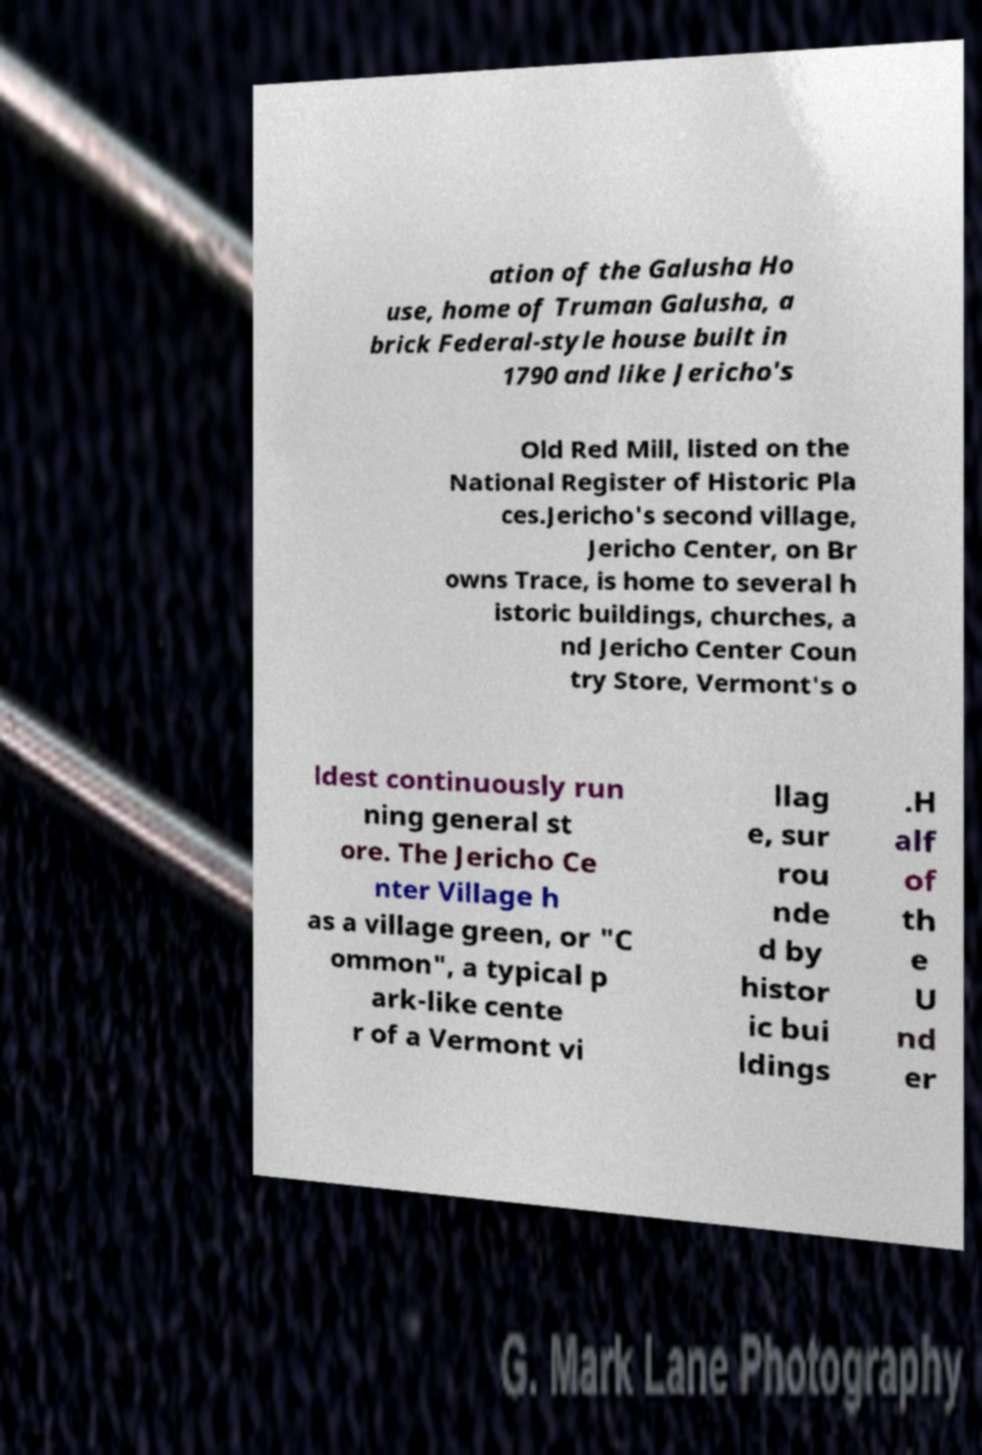Can you accurately transcribe the text from the provided image for me? ation of the Galusha Ho use, home of Truman Galusha, a brick Federal-style house built in 1790 and like Jericho's Old Red Mill, listed on the National Register of Historic Pla ces.Jericho's second village, Jericho Center, on Br owns Trace, is home to several h istoric buildings, churches, a nd Jericho Center Coun try Store, Vermont's o ldest continuously run ning general st ore. The Jericho Ce nter Village h as a village green, or "C ommon", a typical p ark-like cente r of a Vermont vi llag e, sur rou nde d by histor ic bui ldings .H alf of th e U nd er 